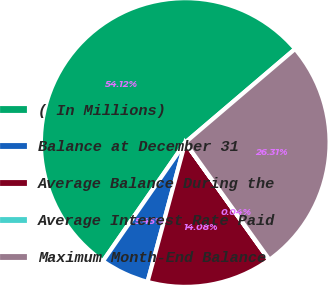<chart> <loc_0><loc_0><loc_500><loc_500><pie_chart><fcel>( In Millions)<fcel>Balance at December 31<fcel>Average Balance During the<fcel>Average Interest Rate Paid<fcel>Maximum Month-End Balance<nl><fcel>54.11%<fcel>5.45%<fcel>14.08%<fcel>0.04%<fcel>26.31%<nl></chart> 